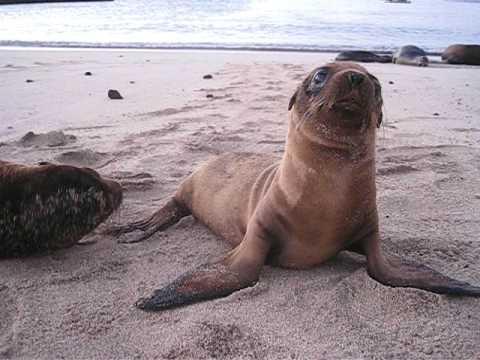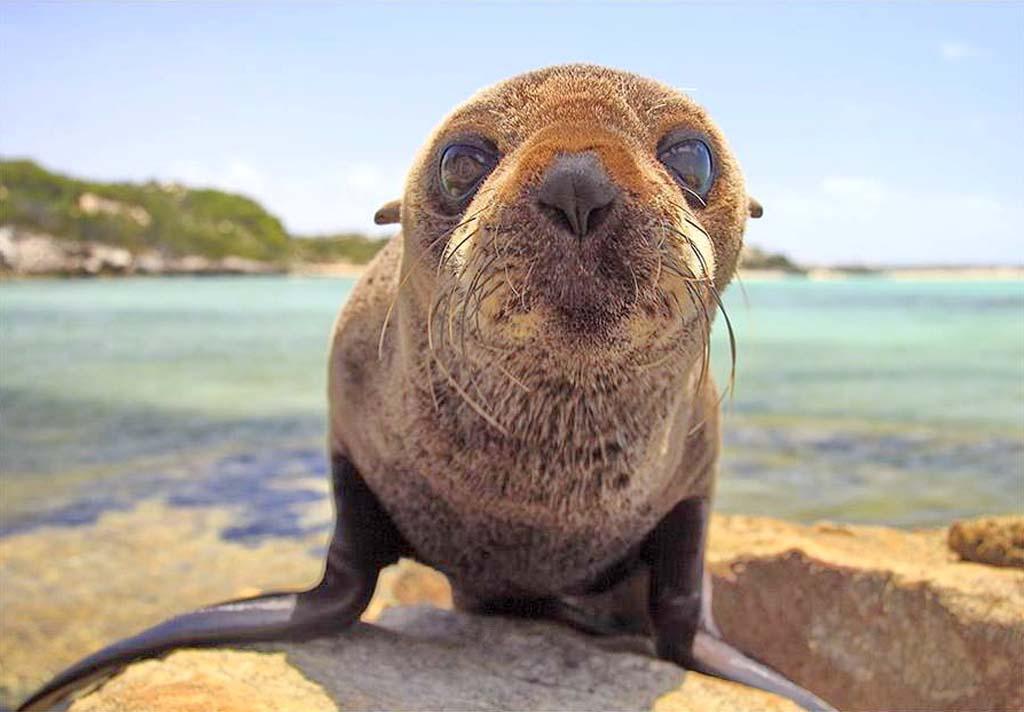The first image is the image on the left, the second image is the image on the right. Evaluate the accuracy of this statement regarding the images: "At least one sea lion is facing left". Is it true? Answer yes or no. No. The first image is the image on the left, the second image is the image on the right. For the images shown, is this caption "Right image features one close-mouthed brown baby seal starting into the camera." true? Answer yes or no. Yes. 